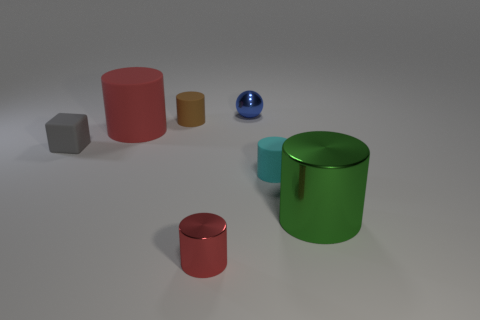Is there anything else that has the same size as the cyan matte thing?
Provide a succinct answer. Yes. There is a red object that is behind the green cylinder; is it the same shape as the small thing that is in front of the large green metallic thing?
Provide a short and direct response. Yes. What is the size of the red metal thing?
Provide a succinct answer. Small. There is a red thing that is in front of the red cylinder that is to the left of the small metal object in front of the matte block; what is its material?
Provide a short and direct response. Metal. How many other objects are there of the same color as the big rubber thing?
Offer a terse response. 1. How many brown things are tiny metallic balls or tiny matte cylinders?
Keep it short and to the point. 1. What material is the tiny cylinder in front of the tiny cyan thing?
Your response must be concise. Metal. Do the tiny cylinder behind the tiny gray thing and the green thing have the same material?
Offer a very short reply. No. What shape is the tiny blue metallic thing?
Offer a terse response. Sphere. There is a tiny shiny object that is on the right side of the shiny object in front of the green cylinder; what number of tiny cylinders are to the left of it?
Your response must be concise. 2. 